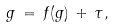Convert formula to latex. <formula><loc_0><loc_0><loc_500><loc_500>g \, = \, f ( g ) \, + \, \tau ,</formula> 